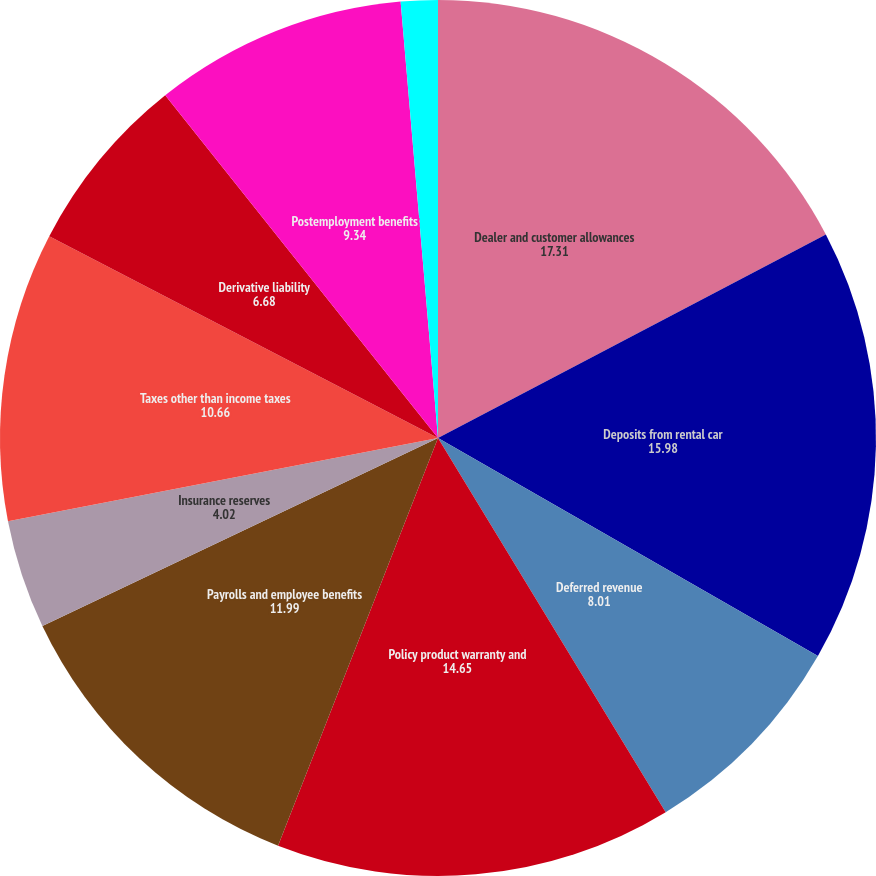Convert chart. <chart><loc_0><loc_0><loc_500><loc_500><pie_chart><fcel>Dealer and customer allowances<fcel>Deposits from rental car<fcel>Deferred revenue<fcel>Policy product warranty and<fcel>Payrolls and employee benefits<fcel>Insurance reserves<fcel>Taxes other than income taxes<fcel>Derivative liability<fcel>Postemployment benefits<fcel>Interest<nl><fcel>17.31%<fcel>15.98%<fcel>8.01%<fcel>14.65%<fcel>11.99%<fcel>4.02%<fcel>10.66%<fcel>6.68%<fcel>9.34%<fcel>1.36%<nl></chart> 